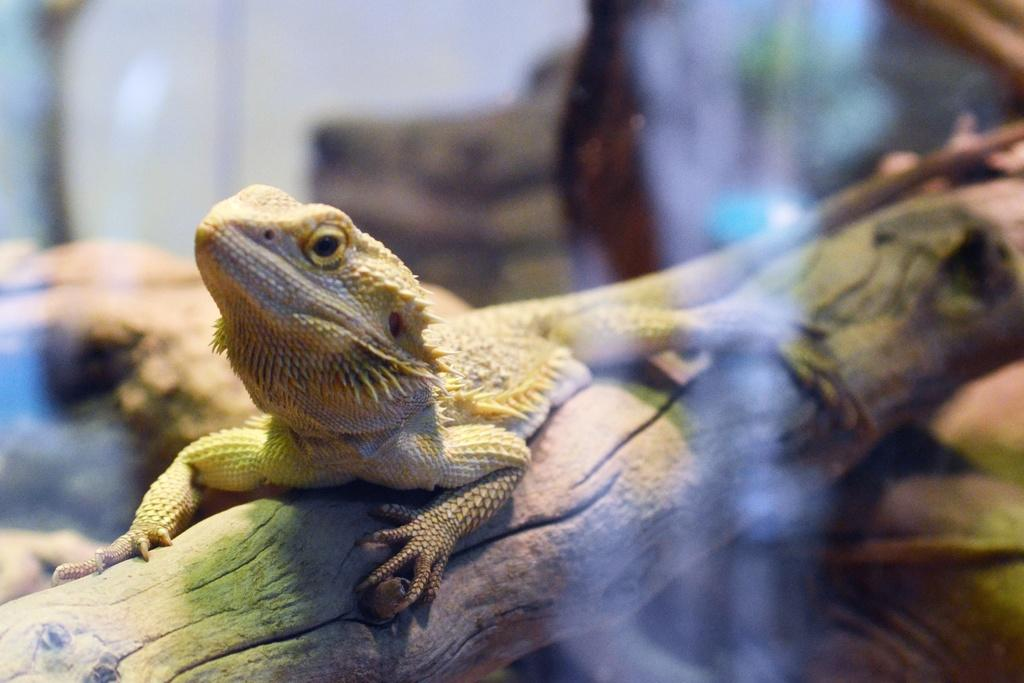What type of animal is in the image? There is a lizard in the image. Where is the lizard located? The lizard is on a branch. Can you describe the background of the image? The background of the image is blurred. What type of coat is the lizard wearing in the image? The lizard is not wearing a coat in the image; it is a reptile and does not wear clothing. 